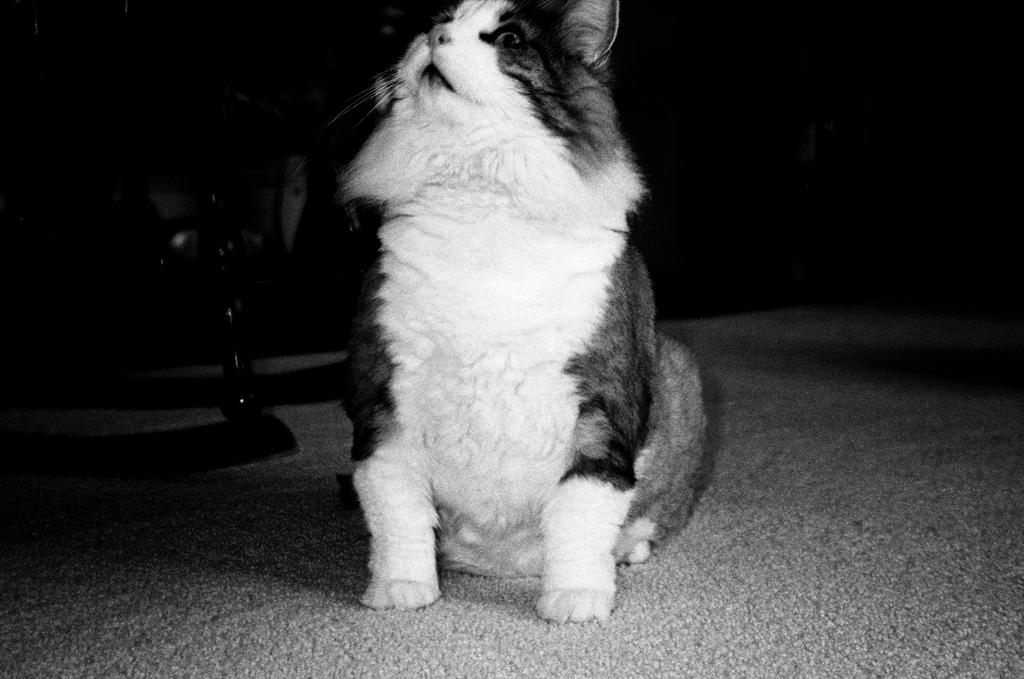What type of animal is in the image? There is a cat in the image. Where is the cat located in the image? The cat is seated on the floor. What type of attack is the cat performing in the image? There is no attack being performed in the image; the cat is simply seated on the floor. 